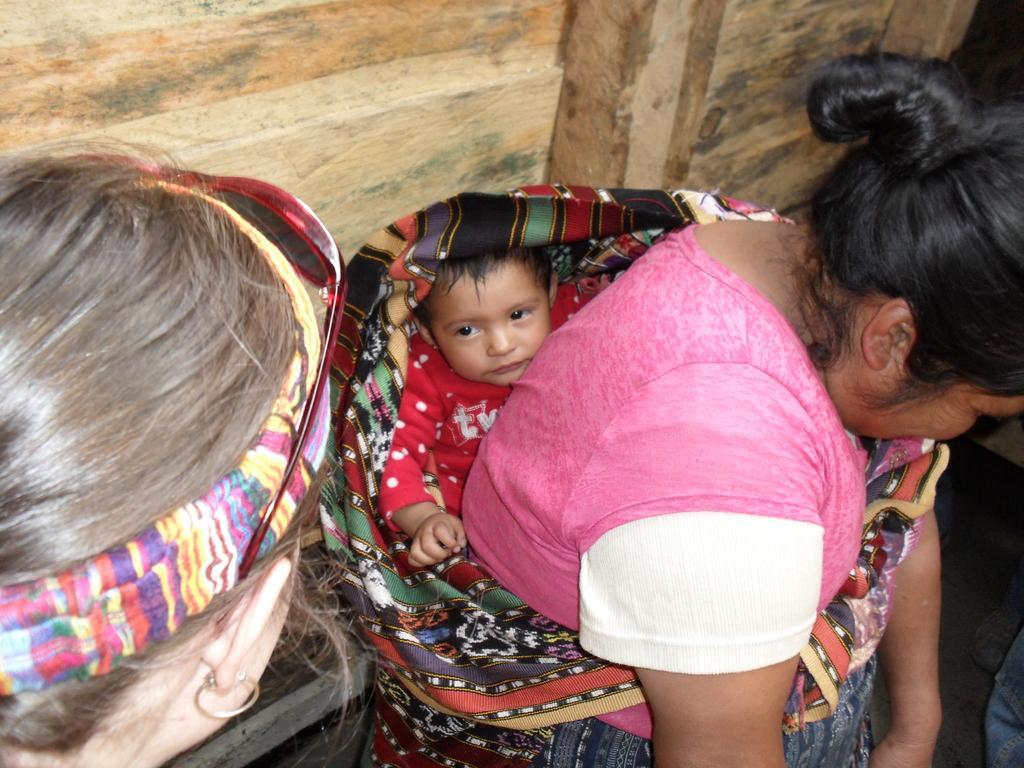In one or two sentences, can you explain what this image depicts? In this image there are persons in the center the woman in the center is holding a child. 